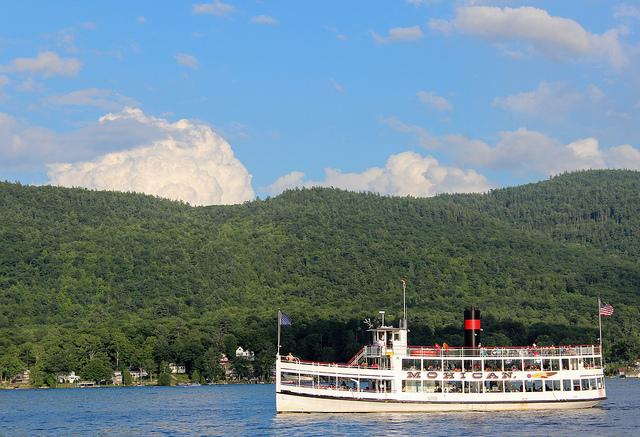Who is on the boat? Please explain your reasoning. tourists. This is a tour boat. the people on the boat are tourists. 